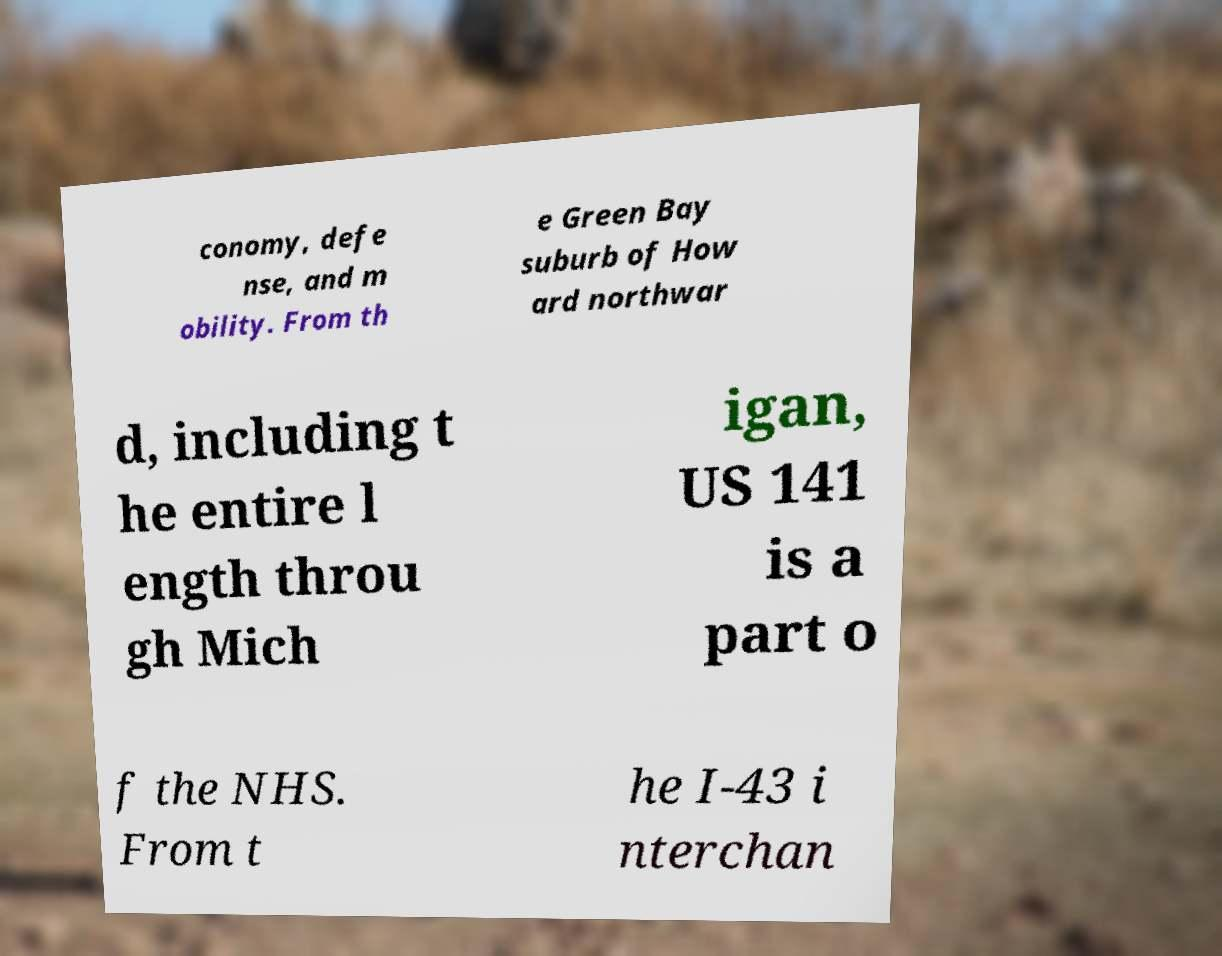What messages or text are displayed in this image? I need them in a readable, typed format. conomy, defe nse, and m obility. From th e Green Bay suburb of How ard northwar d, including t he entire l ength throu gh Mich igan, US 141 is a part o f the NHS. From t he I-43 i nterchan 